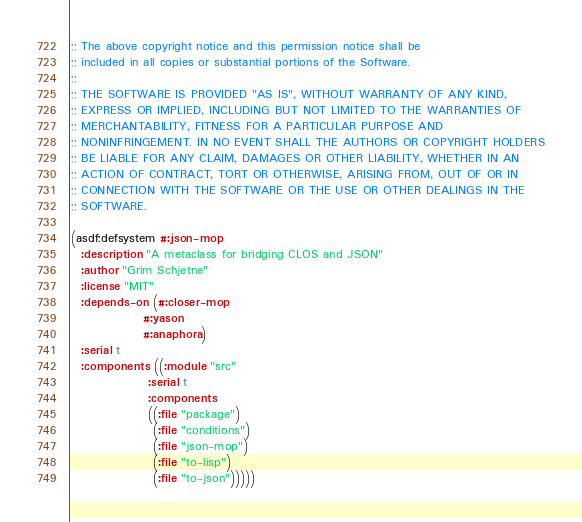<code> <loc_0><loc_0><loc_500><loc_500><_Lisp_>;; The above copyright notice and this permission notice shall be
;; included in all copies or substantial portions of the Software.
;;
;; THE SOFTWARE IS PROVIDED "AS IS", WITHOUT WARRANTY OF ANY KIND,
;; EXPRESS OR IMPLIED, INCLUDING BUT NOT LIMITED TO THE WARRANTIES OF
;; MERCHANTABILITY, FITNESS FOR A PARTICULAR PURPOSE AND
;; NONINFRINGEMENT. IN NO EVENT SHALL THE AUTHORS OR COPYRIGHT HOLDERS
;; BE LIABLE FOR ANY CLAIM, DAMAGES OR OTHER LIABILITY, WHETHER IN AN
;; ACTION OF CONTRACT, TORT OR OTHERWISE, ARISING FROM, OUT OF OR IN
;; CONNECTION WITH THE SOFTWARE OR THE USE OR OTHER DEALINGS IN THE
;; SOFTWARE.

(asdf:defsystem #:json-mop
  :description "A metaclass for bridging CLOS and JSON"
  :author "Grim Schjetne"
  :license "MIT"
  :depends-on (#:closer-mop
               #:yason
               #:anaphora)
  :serial t
  :components ((:module "src"
                :serial t
                :components
                ((:file "package")
                 (:file "conditions")
                 (:file "json-mop")
                 (:file "to-lisp")
                 (:file "to-json")))))
</code> 